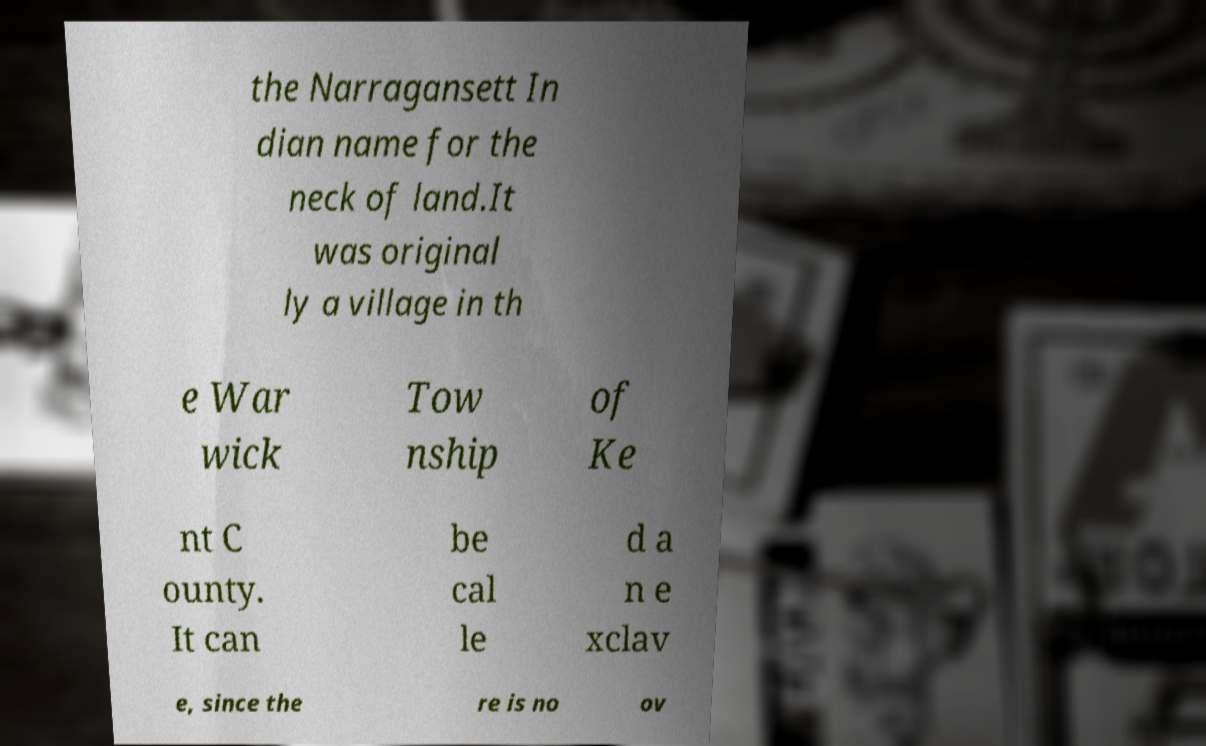Can you accurately transcribe the text from the provided image for me? the Narragansett In dian name for the neck of land.It was original ly a village in th e War wick Tow nship of Ke nt C ounty. It can be cal le d a n e xclav e, since the re is no ov 